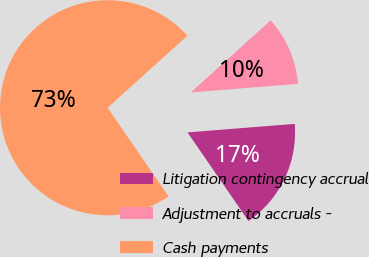Convert chart to OTSL. <chart><loc_0><loc_0><loc_500><loc_500><pie_chart><fcel>Litigation contingency accrual<fcel>Adjustment to accruals -<fcel>Cash payments<nl><fcel>16.67%<fcel>10.42%<fcel>72.92%<nl></chart> 